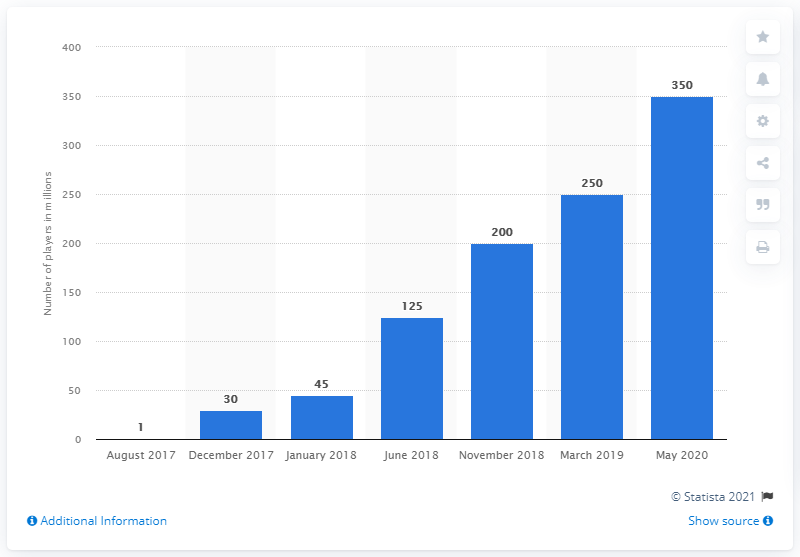Identify some key points in this picture. As of May 2020, it is estimated that 350 players were actively playing Fortnite. Fortnite users who registered after November 2018 numbered approximately 150. 